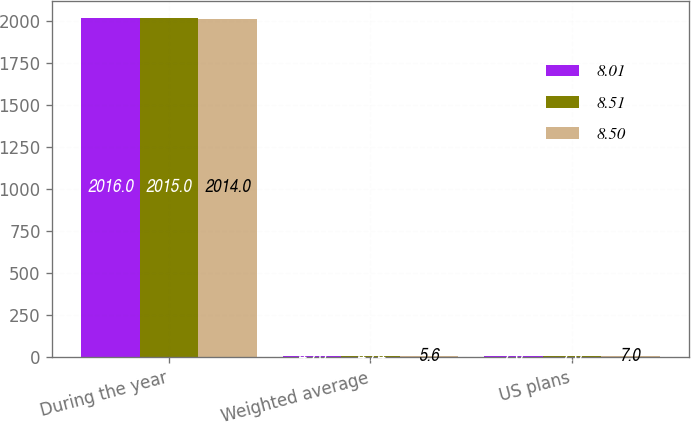Convert chart to OTSL. <chart><loc_0><loc_0><loc_500><loc_500><stacked_bar_chart><ecel><fcel>During the year<fcel>Weighted average<fcel>US plans<nl><fcel>8.01<fcel>2016<fcel>4.76<fcel>7<nl><fcel>8.51<fcel>2015<fcel>4.74<fcel>7<nl><fcel>8.5<fcel>2014<fcel>5.6<fcel>7<nl></chart> 